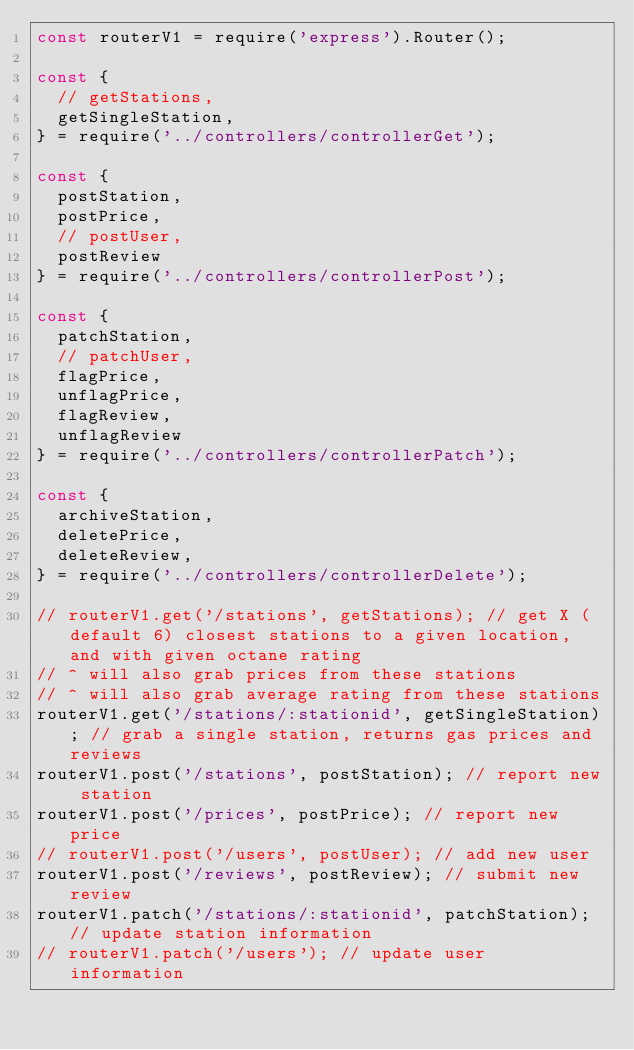Convert code to text. <code><loc_0><loc_0><loc_500><loc_500><_JavaScript_>const routerV1 = require('express').Router();

const {
  // getStations,
  getSingleStation,
} = require('../controllers/controllerGet');

const {
  postStation,
  postPrice,
  // postUser,
  postReview
} = require('../controllers/controllerPost');

const {
  patchStation,
  // patchUser,
  flagPrice,
  unflagPrice,
  flagReview,
  unflagReview
} = require('../controllers/controllerPatch');

const {
  archiveStation,
  deletePrice,
  deleteReview,
} = require('../controllers/controllerDelete');

// routerV1.get('/stations', getStations); // get X (default 6) closest stations to a given location, and with given octane rating
// ^ will also grab prices from these stations
// ^ will also grab average rating from these stations
routerV1.get('/stations/:stationid', getSingleStation); // grab a single station, returns gas prices and reviews
routerV1.post('/stations', postStation); // report new station
routerV1.post('/prices', postPrice); // report new price
// routerV1.post('/users', postUser); // add new user
routerV1.post('/reviews', postReview); // submit new review
routerV1.patch('/stations/:stationid', patchStation); // update station information
// routerV1.patch('/users'); // update user information </code> 